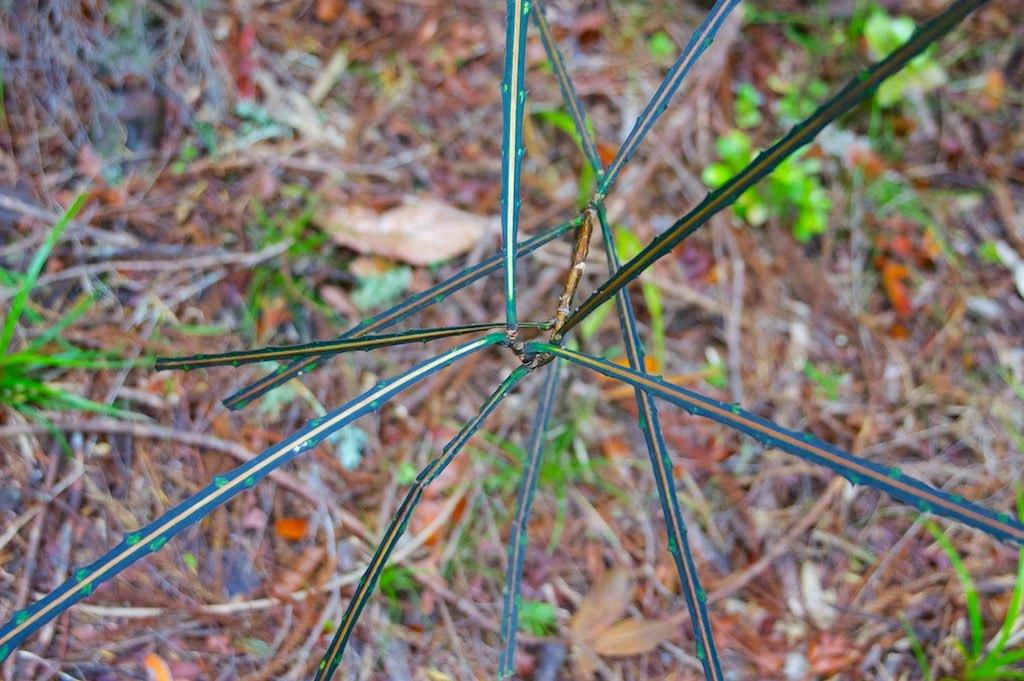What type of living organism can be seen in the image? There is a plant in the image. What can be found on the ground in the image? There are dry leaves on the ground in the image. What type of road can be seen in the image? There is no road present in the image; it only features a plant and dry leaves on the ground. What type of authority is depicted in the image? There is no authority figure present in the image; it only features a plant and dry leaves on the ground. 